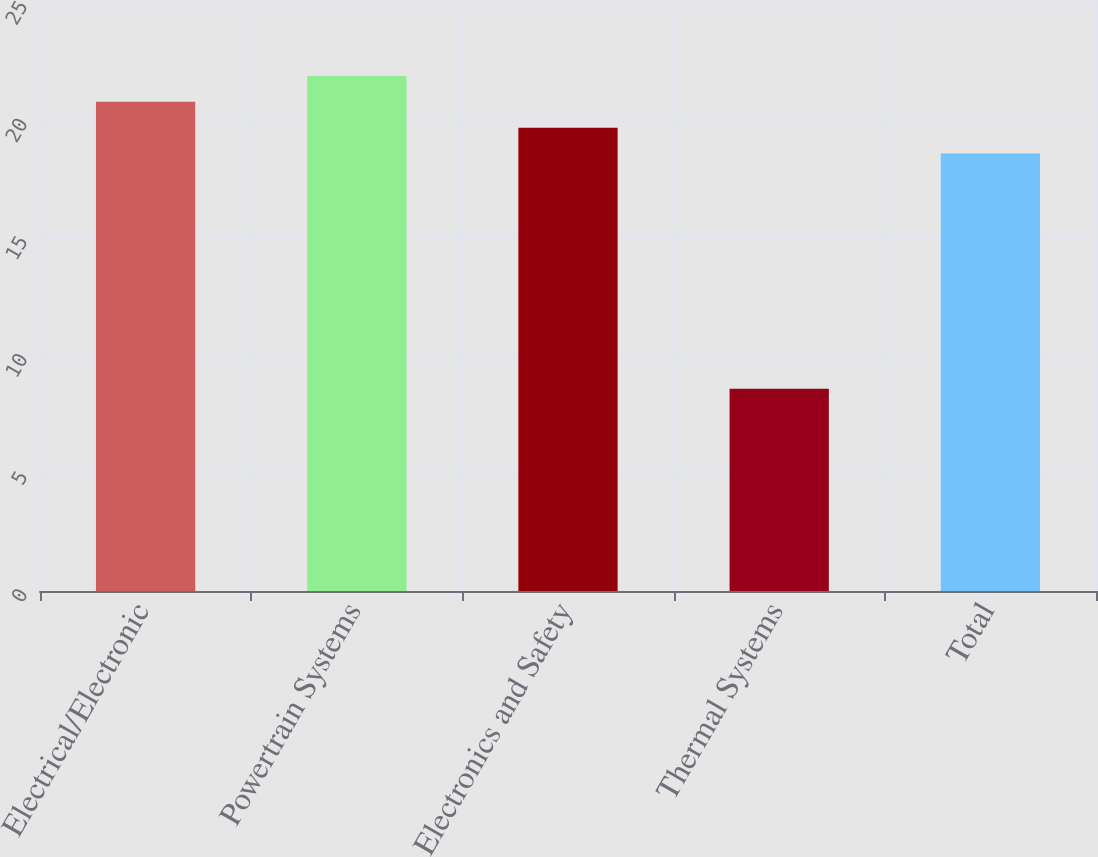Convert chart. <chart><loc_0><loc_0><loc_500><loc_500><bar_chart><fcel>Electrical/Electronic<fcel>Powertrain Systems<fcel>Electronics and Safety<fcel>Thermal Systems<fcel>Total<nl><fcel>20.8<fcel>21.9<fcel>19.7<fcel>8.6<fcel>18.6<nl></chart> 